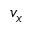<formula> <loc_0><loc_0><loc_500><loc_500>v _ { x }</formula> 